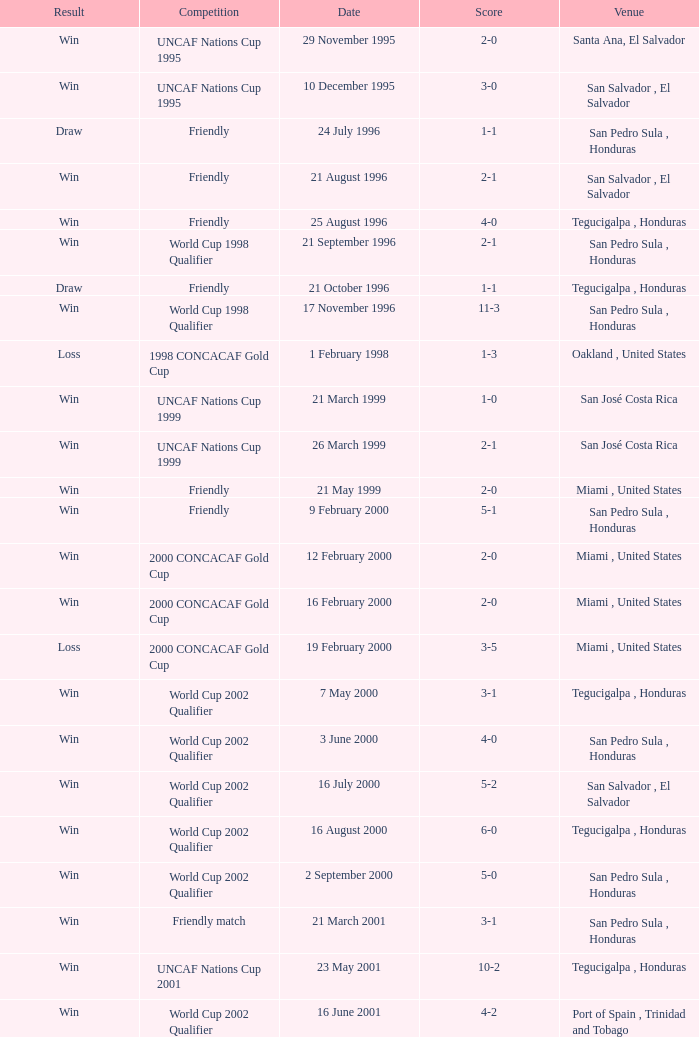Could you parse the entire table? {'header': ['Result', 'Competition', 'Date', 'Score', 'Venue'], 'rows': [['Win', 'UNCAF Nations Cup 1995', '29 November 1995', '2-0', 'Santa Ana, El Salvador'], ['Win', 'UNCAF Nations Cup 1995', '10 December 1995', '3-0', 'San Salvador , El Salvador'], ['Draw', 'Friendly', '24 July 1996', '1-1', 'San Pedro Sula , Honduras'], ['Win', 'Friendly', '21 August 1996', '2-1', 'San Salvador , El Salvador'], ['Win', 'Friendly', '25 August 1996', '4-0', 'Tegucigalpa , Honduras'], ['Win', 'World Cup 1998 Qualifier', '21 September 1996', '2-1', 'San Pedro Sula , Honduras'], ['Draw', 'Friendly', '21 October 1996', '1-1', 'Tegucigalpa , Honduras'], ['Win', 'World Cup 1998 Qualifier', '17 November 1996', '11-3', 'San Pedro Sula , Honduras'], ['Loss', '1998 CONCACAF Gold Cup', '1 February 1998', '1-3', 'Oakland , United States'], ['Win', 'UNCAF Nations Cup 1999', '21 March 1999', '1-0', 'San José Costa Rica'], ['Win', 'UNCAF Nations Cup 1999', '26 March 1999', '2-1', 'San José Costa Rica'], ['Win', 'Friendly', '21 May 1999', '2-0', 'Miami , United States'], ['Win', 'Friendly', '9 February 2000', '5-1', 'San Pedro Sula , Honduras'], ['Win', '2000 CONCACAF Gold Cup', '12 February 2000', '2-0', 'Miami , United States'], ['Win', '2000 CONCACAF Gold Cup', '16 February 2000', '2-0', 'Miami , United States'], ['Loss', '2000 CONCACAF Gold Cup', '19 February 2000', '3-5', 'Miami , United States'], ['Win', 'World Cup 2002 Qualifier', '7 May 2000', '3-1', 'Tegucigalpa , Honduras'], ['Win', 'World Cup 2002 Qualifier', '3 June 2000', '4-0', 'San Pedro Sula , Honduras'], ['Win', 'World Cup 2002 Qualifier', '16 July 2000', '5-2', 'San Salvador , El Salvador'], ['Win', 'World Cup 2002 Qualifier', '16 August 2000', '6-0', 'Tegucigalpa , Honduras'], ['Win', 'World Cup 2002 Qualifier', '2 September 2000', '5-0', 'San Pedro Sula , Honduras'], ['Win', 'Friendly match', '21 March 2001', '3-1', 'San Pedro Sula , Honduras'], ['Win', 'UNCAF Nations Cup 2001', '23 May 2001', '10-2', 'Tegucigalpa , Honduras'], ['Win', 'World Cup 2002 Qualifier', '16 June 2001', '4-2', 'Port of Spain , Trinidad and Tobago'], ['Win', 'World Cup 2002 Qualifier', '20 June 2001', '3-1', 'San Pedro Sula , Honduras'], ['Win', 'World Cup 2002 Qualifier', '1 September 2001', '2-1', 'Washington, D.C. , United States'], ['Draw', 'Carlsberg Cup', '2 May 2002', '3-3', 'Kobe , Japan'], ['Draw', 'Friendly', '28 April 2004', '1-1', 'Fort Lauderdale , United States'], ['Win', 'World Cup 2006 Qualification', '19 June 2004', '4-0', 'San Pedro Sula , Honduras'], ['Loss', 'Friendly', '19 April 2007', '1-3', 'La Ceiba , Honduras'], ['Loss', 'Friendly', '25 May 2007', '1-2', 'Mérida , Venezuela'], ['Win', '2007 CONCACAF Gold Cup', '13 June 2007', '5-0', 'Houston , United States'], ['Loss', '2007 CONCACAF Gold Cup', '17 June 2007', '1-2', 'Houston , United States'], ['Win', 'Friendly', '18 January 2009', '2-0', 'Miami , United States'], ['Win', 'UNCAF Nations Cup 2009', '26 January 2009', '2-0', 'Tegucigalpa , Honduras'], ['Draw', 'World Cup 2010 Qualification', '28 March 2009', '1-1', 'Port of Spain , Trinidad and Tobago'], ['Win', 'World Cup 2010 Qualification', '1 April 2009', '3-1', 'San Pedro Sula , Honduras'], ['Win', 'World Cup 2010 Qualification', '10 June 2009', '1-0', 'San Pedro Sula , Honduras'], ['Win', 'World Cup 2010 Qualification', '12 August 2009', '4-0', 'San Pedro Sula , Honduras'], ['Win', 'World Cup 2010 Qualification', '5 September 2009', '4-1', 'San Pedro Sula , Honduras'], ['Win', 'World Cup 2010 Qualification', '14 October 2009', '1-0', 'San Salvador , El Salvador'], ['Win', 'Friendly', '23 January 2010', '3-1', 'Carson , United States']]} Name the score for 7 may 2000 3-1. 